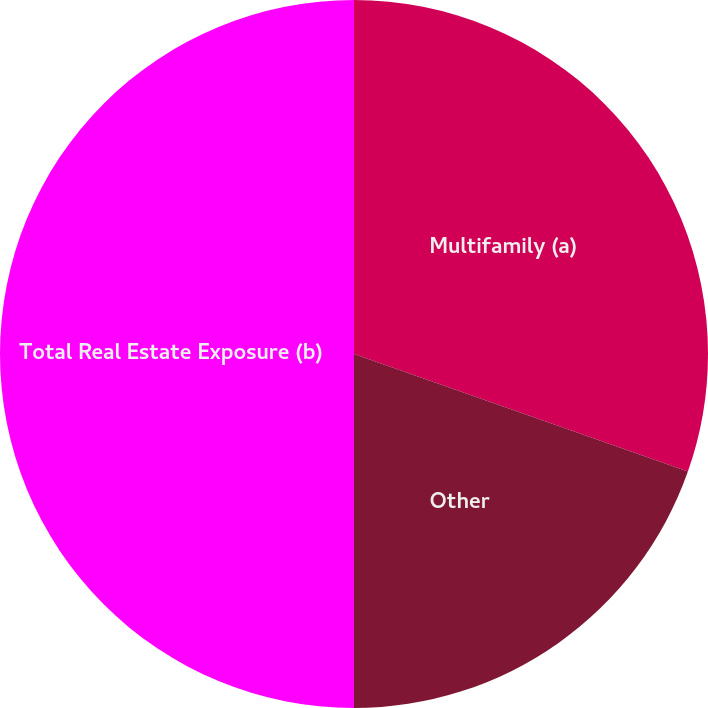Convert chart to OTSL. <chart><loc_0><loc_0><loc_500><loc_500><pie_chart><fcel>Multifamily (a)<fcel>Other<fcel>Total Real Estate Exposure (b)<nl><fcel>30.39%<fcel>19.61%<fcel>50.0%<nl></chart> 